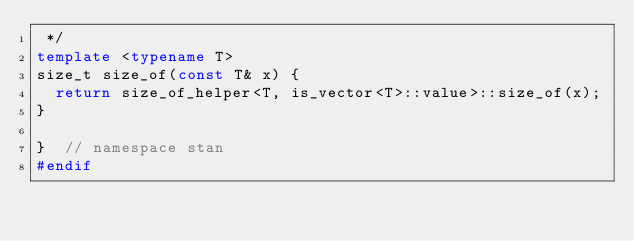<code> <loc_0><loc_0><loc_500><loc_500><_C++_> */
template <typename T>
size_t size_of(const T& x) {
  return size_of_helper<T, is_vector<T>::value>::size_of(x);
}

}  // namespace stan
#endif
</code> 